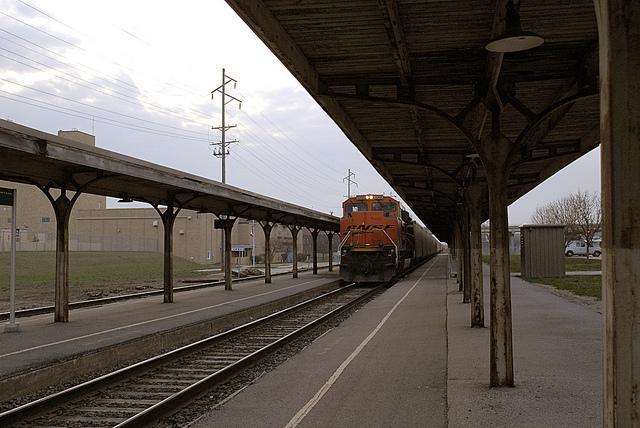Do the trains run on electricity?
Short answer required. No. Is this a big railway station?
Answer briefly. No. How many sets of train tracks are there?
Give a very brief answer. 1. What color vehicle is parked in the background on the right?
Write a very short answer. White. Is this a train intersection?
Keep it brief. No. What is the train on the left doing?
Short answer required. Riding. How many trains are there?
Answer briefly. 1. How many train tracks are there in this picture?
Be succinct. 1. 